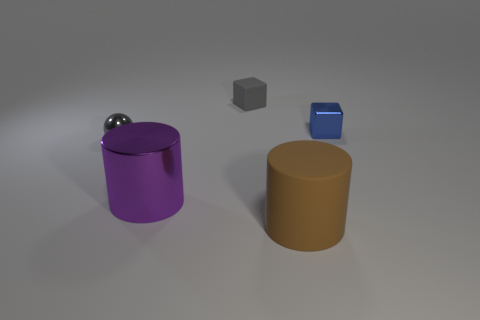What number of other things are there of the same shape as the purple metallic object?
Offer a terse response. 1. The small shiny thing that is behind the tiny gray metal object has what shape?
Keep it short and to the point. Cube. Do the purple object and the big thing right of the gray matte block have the same shape?
Ensure brevity in your answer.  Yes. There is a shiny thing that is both on the left side of the brown rubber thing and right of the tiny gray metal sphere; how big is it?
Give a very brief answer. Large. There is a thing that is both to the right of the gray matte block and behind the gray ball; what is its color?
Offer a terse response. Blue. Are there fewer large rubber cylinders that are right of the brown rubber cylinder than small metallic things to the left of the tiny blue cube?
Your answer should be very brief. Yes. Are there any other things that have the same color as the large matte thing?
Give a very brief answer. No. What shape is the gray matte thing?
Give a very brief answer. Cube. There is a cube that is made of the same material as the brown cylinder; what color is it?
Make the answer very short. Gray. Is the number of large things greater than the number of small objects?
Ensure brevity in your answer.  No. 